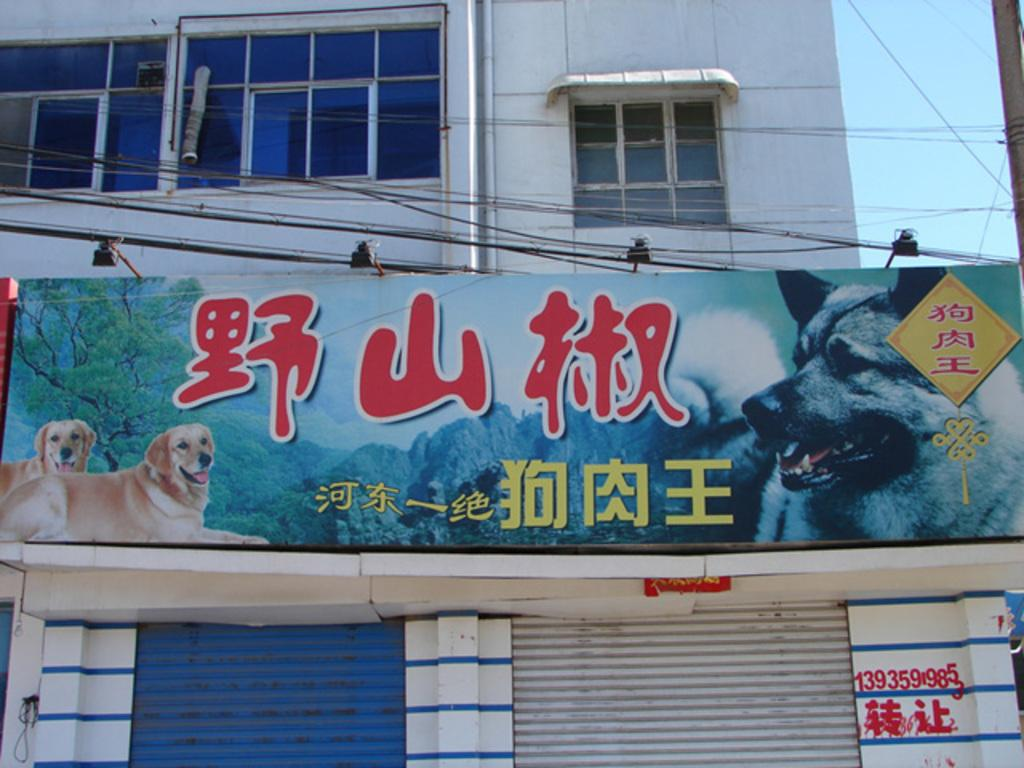What structure is featured in the image? There is a board to a building in the image. What architectural feature of the building is visible? There are windows to the building in the image. What object is located to the right in the image? There is a pole to the right in the image. What is visible in the background of the image? The sky is visible in the image. What type of print can be seen on the gold spot in the image? There is no print, gold, or spot present in the image. 